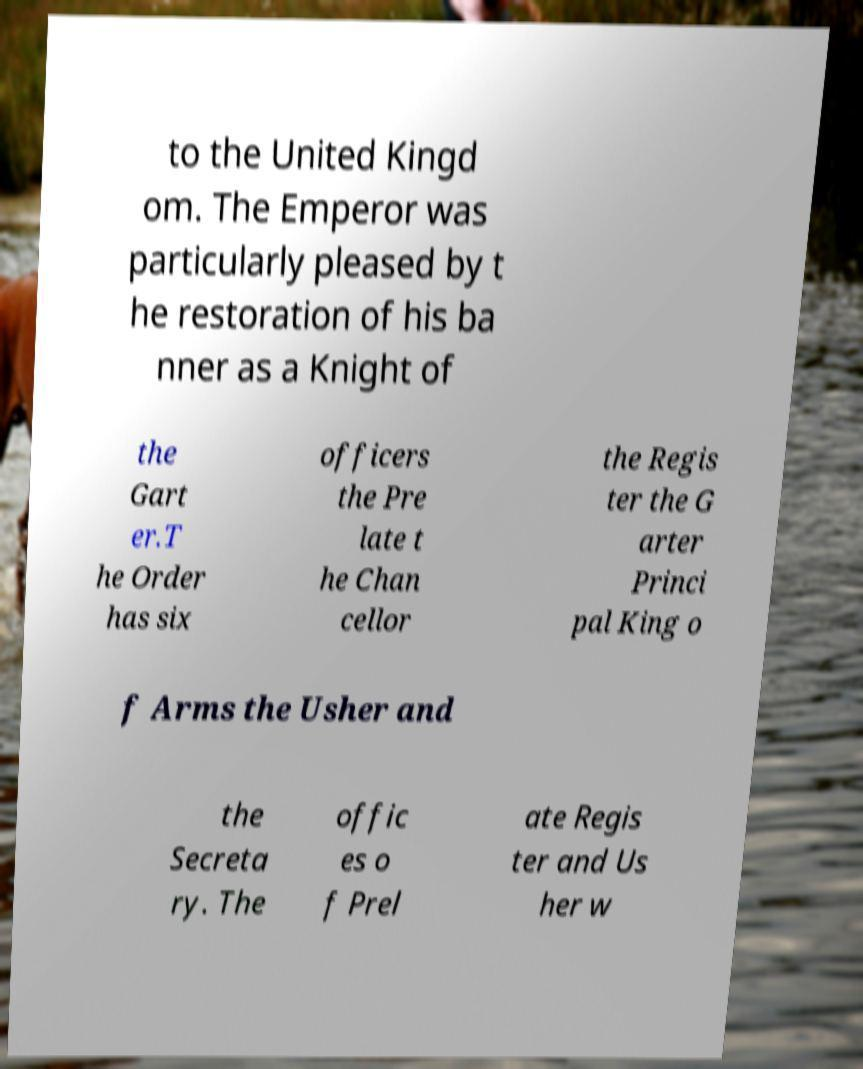Can you read and provide the text displayed in the image?This photo seems to have some interesting text. Can you extract and type it out for me? to the United Kingd om. The Emperor was particularly pleased by t he restoration of his ba nner as a Knight of the Gart er.T he Order has six officers the Pre late t he Chan cellor the Regis ter the G arter Princi pal King o f Arms the Usher and the Secreta ry. The offic es o f Prel ate Regis ter and Us her w 